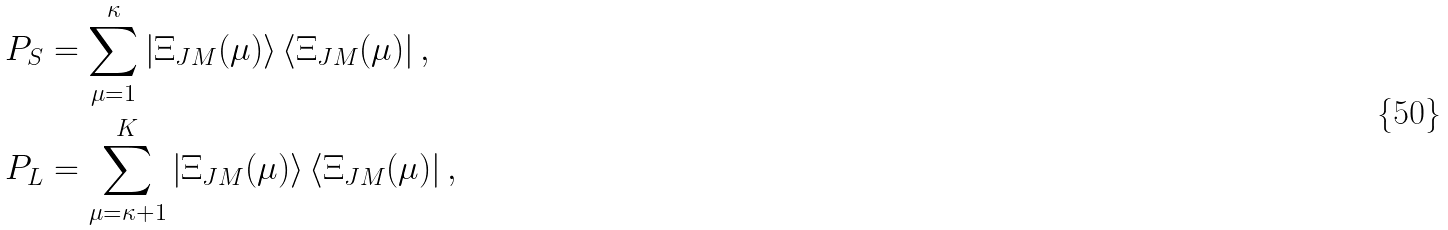<formula> <loc_0><loc_0><loc_500><loc_500>& P _ { S } = \sum _ { \mu = 1 } ^ { \kappa } \left | \Xi _ { J M } ( \mu ) \right > \left < \Xi _ { J M } ( \mu ) \right | , \\ & P _ { L } = \sum _ { \mu = \kappa + 1 } ^ { K } \left | \Xi _ { J M } ( \mu ) \right > \left < \Xi _ { J M } ( \mu ) \right | ,</formula> 